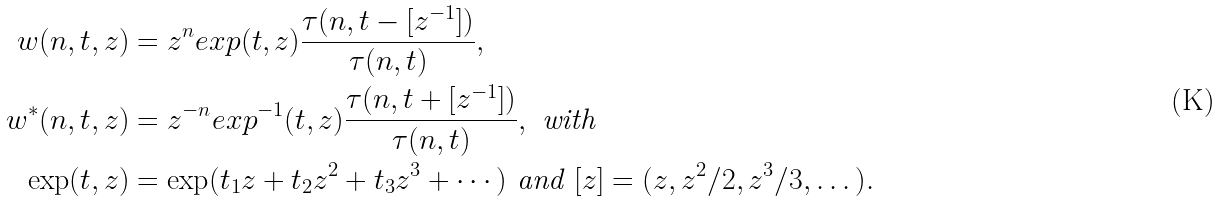<formula> <loc_0><loc_0><loc_500><loc_500>w ( n , t , z ) & = z ^ { n } e x p ( t , z ) \frac { \tau ( n , t - [ z ^ { - 1 } ] ) } { \tau ( n , t ) } , \\ w ^ { * } ( n , t , z ) & = z ^ { - n } e x p ^ { - 1 } ( t , z ) \frac { \tau ( n , t + [ z ^ { - 1 } ] ) } { \tau ( n , t ) } , \text { with } \\ \exp ( t , z ) & = \exp ( t _ { 1 } z + t _ { 2 } z ^ { 2 } + t _ { 3 } z ^ { 3 } + \cdots ) \text { and } [ z ] = ( z , z ^ { 2 } / 2 , z ^ { 3 } / 3 , \dots ) .</formula> 